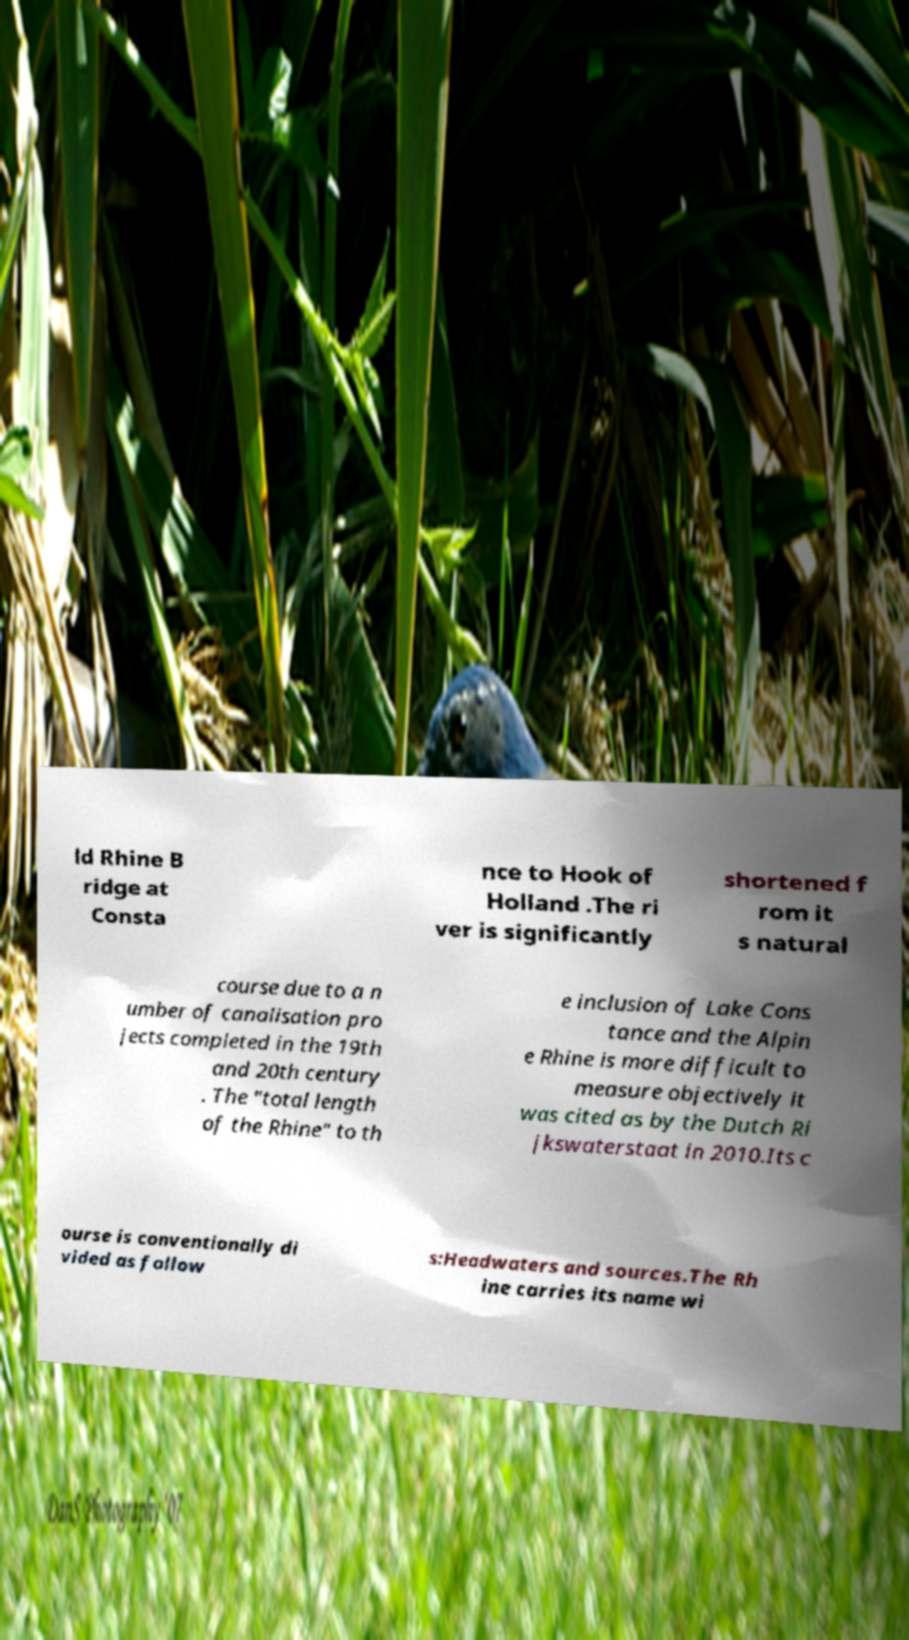For documentation purposes, I need the text within this image transcribed. Could you provide that? ld Rhine B ridge at Consta nce to Hook of Holland .The ri ver is significantly shortened f rom it s natural course due to a n umber of canalisation pro jects completed in the 19th and 20th century . The "total length of the Rhine" to th e inclusion of Lake Cons tance and the Alpin e Rhine is more difficult to measure objectively it was cited as by the Dutch Ri jkswaterstaat in 2010.Its c ourse is conventionally di vided as follow s:Headwaters and sources.The Rh ine carries its name wi 